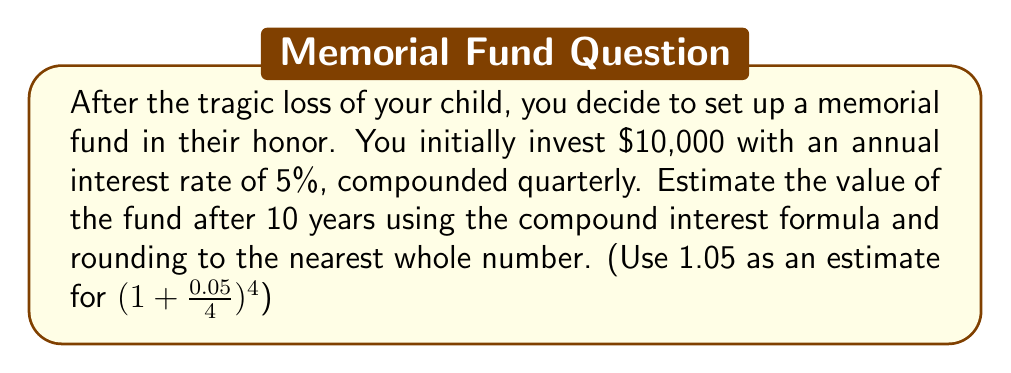Could you help me with this problem? Let's approach this step-by-step:

1) The compound interest formula is:
   $A = P(1 + \frac{r}{n})^{nt}$

   Where:
   $A$ = final amount
   $P$ = principal (initial investment)
   $r$ = annual interest rate (as a decimal)
   $n$ = number of times interest is compounded per year
   $t$ = number of years

2) We're given:
   $P = 10,000$
   $r = 0.05$ (5% as a decimal)
   $n = 4$ (compounded quarterly)
   $t = 10$ years

3) We're told to use 1.05 as an estimate for $(1 + \frac{0.05}{4})^4$. This simplifies our calculation.

4) Using this estimate, we can rewrite our formula as:
   $A = 10,000(1.05)^{10}$

5) Now, let's calculate:
   $A = 10,000 \times 1.05^{10}$
   $A = 10,000 \times 1.6288946$
   $A = 16,288.95$

6) Rounding to the nearest whole number:
   $A \approx 16,289$
Answer: $16,289 